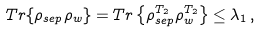<formula> <loc_0><loc_0><loc_500><loc_500>T r \{ \rho _ { s e p } \rho _ { w } \} = T r \left \{ \rho _ { s e p } ^ { T _ { 2 } } \rho _ { w } ^ { T _ { 2 } } \right \} \leq \lambda _ { 1 } \, ,</formula> 